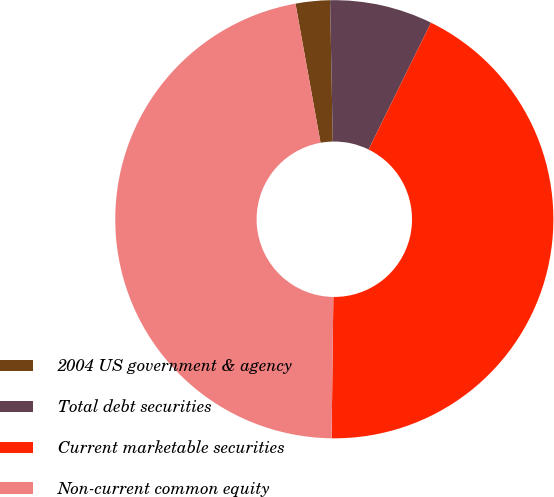Convert chart. <chart><loc_0><loc_0><loc_500><loc_500><pie_chart><fcel>2004 US government & agency<fcel>Total debt securities<fcel>Current marketable securities<fcel>Non-current common equity<nl><fcel>2.53%<fcel>7.58%<fcel>42.93%<fcel>46.97%<nl></chart> 